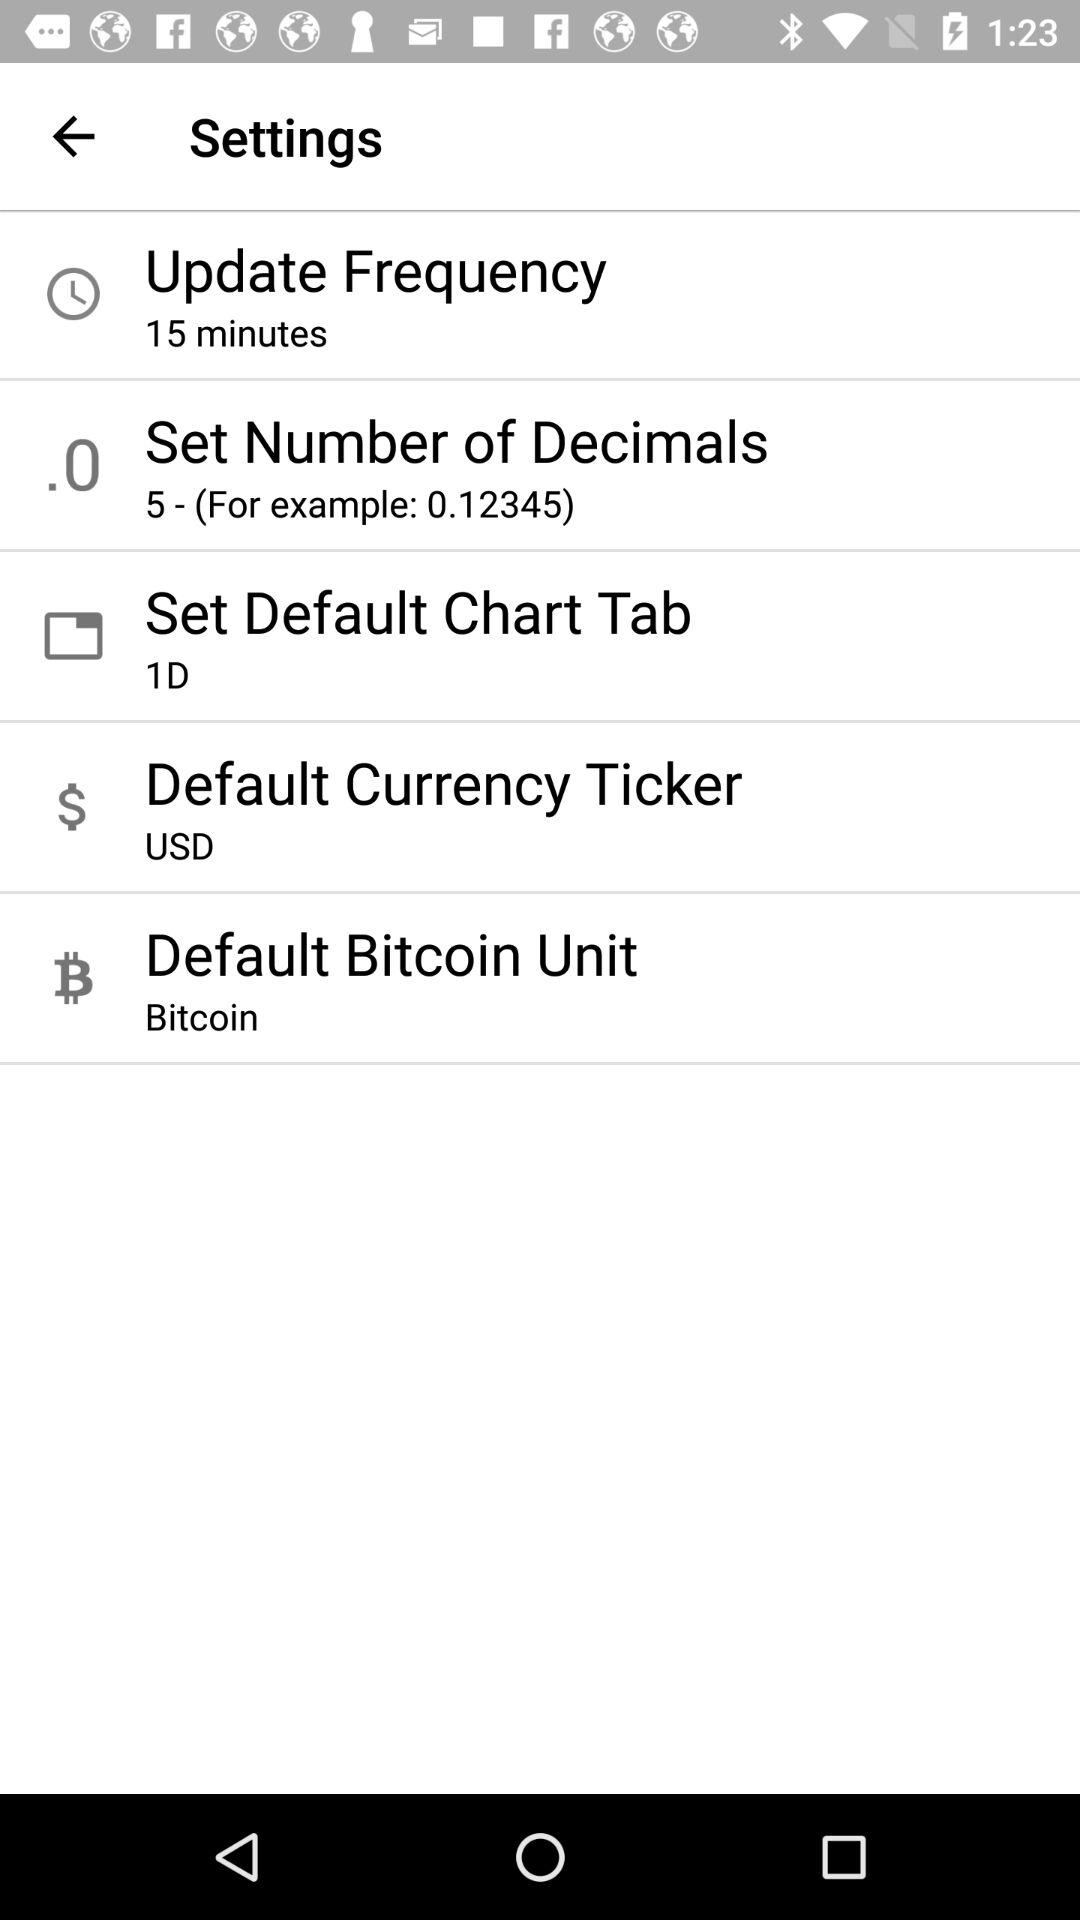What's the shown update frequency? The shown update frequency is "15 minutes". 